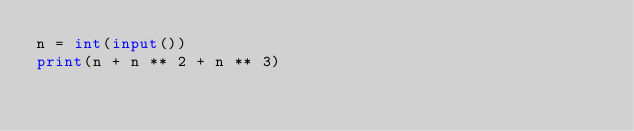<code> <loc_0><loc_0><loc_500><loc_500><_Python_>n = int(input())
print(n + n ** 2 + n ** 3)</code> 